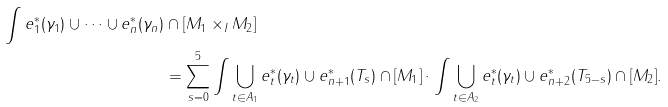<formula> <loc_0><loc_0><loc_500><loc_500>\int e _ { 1 } ^ { * } ( \gamma _ { 1 } ) \cup \dots \cup e _ { n } ^ { * } ( \gamma _ { n } ) & \cap [ M _ { 1 } \times _ { I } M _ { 2 } ] \\ & = \sum _ { s = 0 } ^ { 5 } \int \bigcup _ { t \in A _ { 1 } } e _ { t } ^ { * } ( \gamma _ { t } ) \cup e _ { n + 1 } ^ { * } ( T _ { s } ) \cap [ M _ { 1 } ] \cdot \int \bigcup _ { t \in A _ { 2 } } e _ { t } ^ { * } ( \gamma _ { t } ) \cup e _ { n + 2 } ^ { * } ( T _ { 5 - s } ) \cap [ M _ { 2 } ] .</formula> 